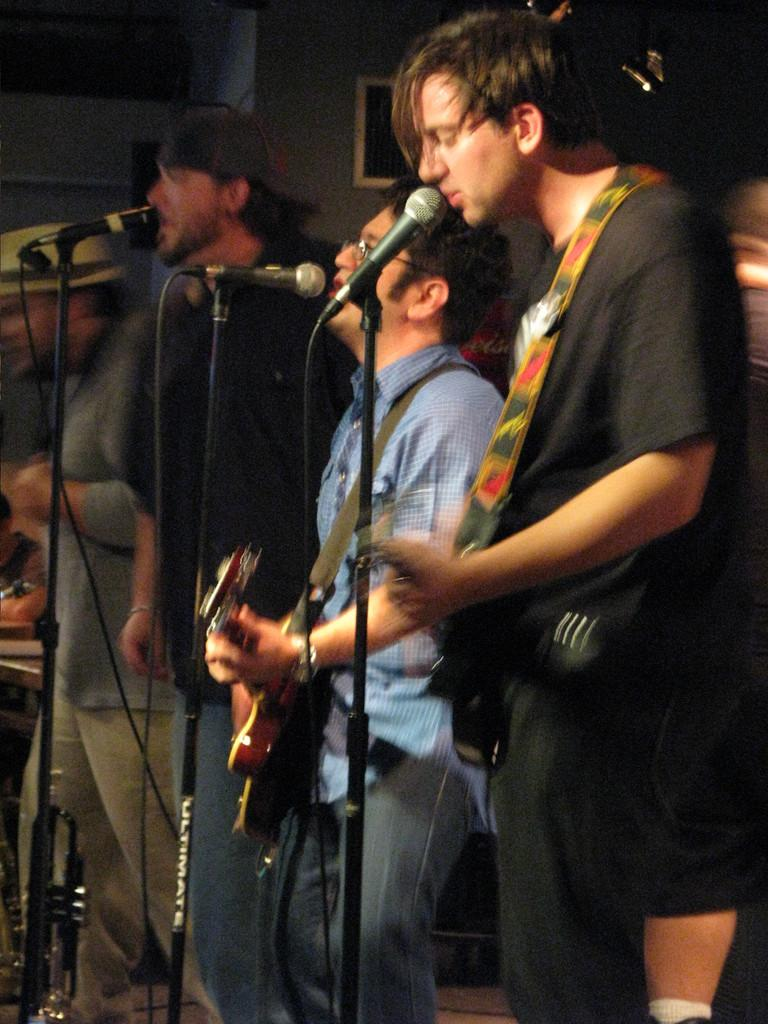What are the people in the image doing? The people in the image are playing musical instruments. What equipment is present to amplify the sound of their instruments? There are microphones on stands in the image. What else can be seen in the image besides the people and microphones? There are cables visible in the image. Can you tell me how many horses are present in the image? There are no horses present in the image; it features people playing musical instruments and related equipment. Is there a war taking place in the image? There is no indication of a war in the image; it depicts a musical performance. 